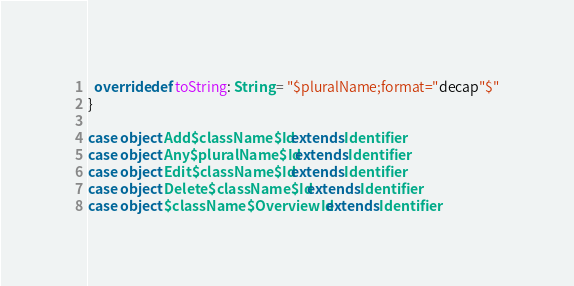<code> <loc_0><loc_0><loc_500><loc_500><_Scala_>  override def toString: String = "$pluralName;format="decap"$"
}

case object Add$className$Id extends Identifier
case object Any$pluralName$Id extends Identifier
case object Edit$className$Id extends Identifier
case object Delete$className$Id extends Identifier
case object $className$OverviewId extends Identifier
</code> 